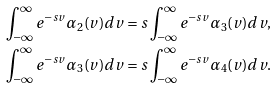Convert formula to latex. <formula><loc_0><loc_0><loc_500><loc_500>\int _ { - \infty } ^ { \infty } e ^ { - s v } \alpha _ { 2 } ( v ) d v & = s \int _ { - \infty } ^ { \infty } e ^ { - s v } \alpha _ { 3 } ( v ) d v , \\ \int _ { - \infty } ^ { \infty } e ^ { - s v } \alpha _ { 3 } ( v ) d v & = s \int _ { - \infty } ^ { \infty } e ^ { - s v } \alpha _ { 4 } ( v ) d v .</formula> 